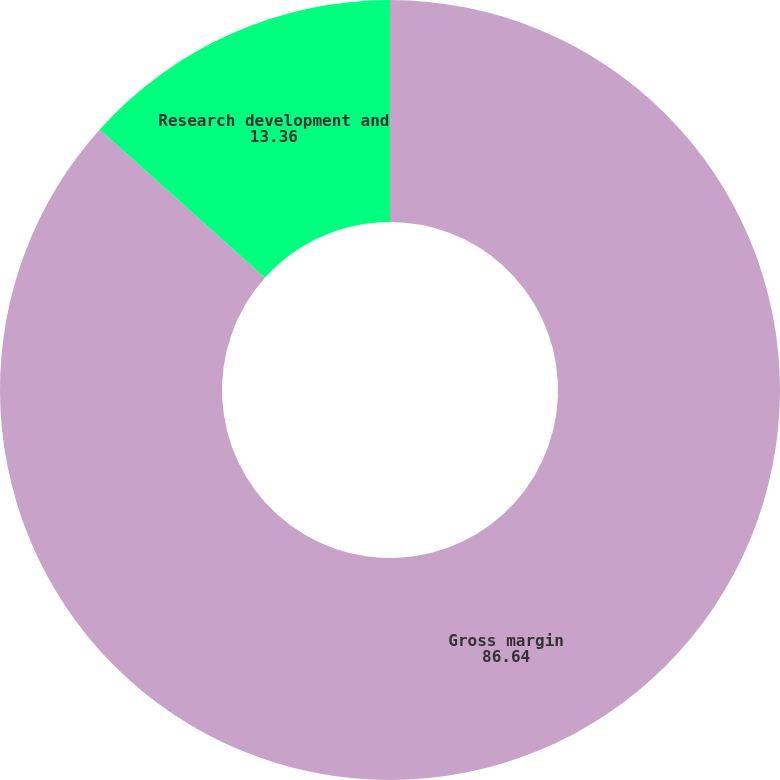Convert chart. <chart><loc_0><loc_0><loc_500><loc_500><pie_chart><fcel>Gross margin<fcel>Research development and<nl><fcel>86.64%<fcel>13.36%<nl></chart> 